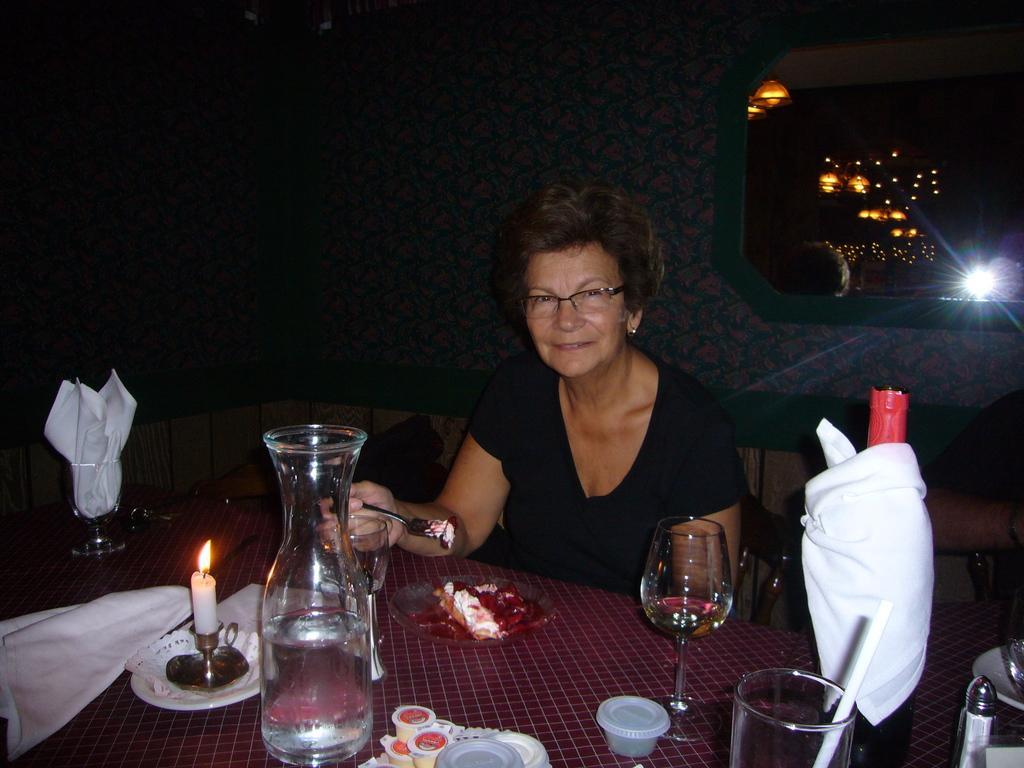Please provide a concise description of this image. In this picture we can see woman sitting on chair and smiling and holding fork in her hand and in front of her on table we have jar with water in it, candle, tissue paper, cloth, bottle and in the background we can see wall, lights. 